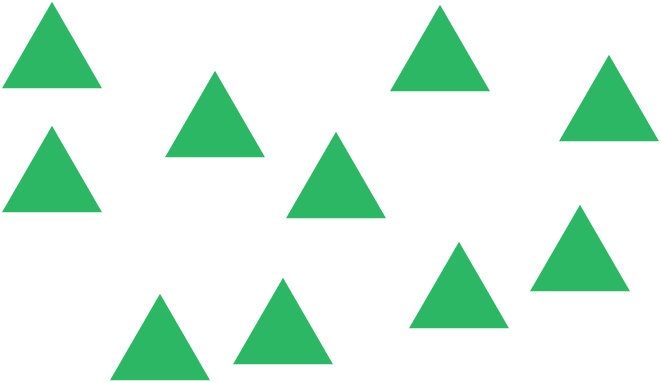I have a question about what is happening in this picture, can you please give me an answer?

How many triangles are there? Upon examining the image, you can clearly see several green triangles. Each triangle is distinct with no overlap, making it easier to count them one by one. If you look carefully starting from the left to the right, or top to bottom, you'll see that there are a total of ten triangles in the image. Understanding and visualizing geometric shapes like these can be a fun and educational exercise in both visual perception and counting! 